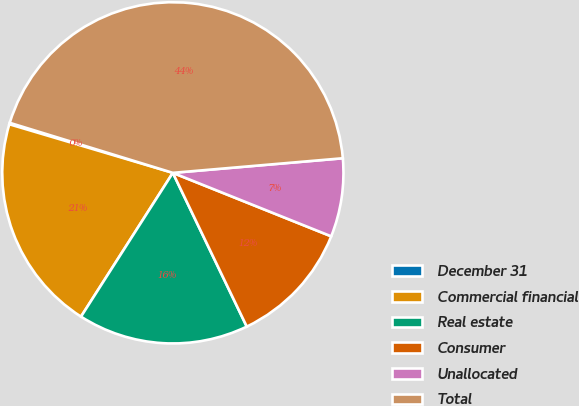Convert chart. <chart><loc_0><loc_0><loc_500><loc_500><pie_chart><fcel>December 31<fcel>Commercial financial<fcel>Real estate<fcel>Consumer<fcel>Unallocated<fcel>Total<nl><fcel>0.14%<fcel>20.55%<fcel>16.18%<fcel>11.8%<fcel>7.43%<fcel>43.9%<nl></chart> 